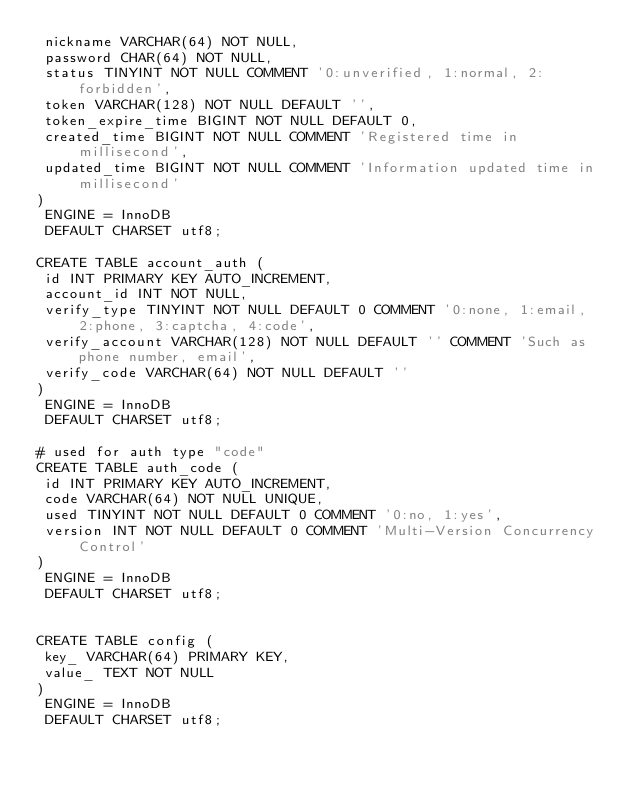<code> <loc_0><loc_0><loc_500><loc_500><_SQL_> nickname VARCHAR(64) NOT NULL,
 password CHAR(64) NOT NULL,
 status TINYINT NOT NULL COMMENT '0:unverified, 1:normal, 2:forbidden',
 token VARCHAR(128) NOT NULL DEFAULT '',
 token_expire_time BIGINT NOT NULL DEFAULT 0,
 created_time BIGINT NOT NULL COMMENT 'Registered time in millisecond',
 updated_time BIGINT NOT NULL COMMENT 'Information updated time in millisecond'
)
 ENGINE = InnoDB
 DEFAULT CHARSET utf8;

CREATE TABLE account_auth (
 id INT PRIMARY KEY AUTO_INCREMENT,
 account_id INT NOT NULL,
 verify_type TINYINT NOT NULL DEFAULT 0 COMMENT '0:none, 1:email, 2:phone, 3:captcha, 4:code',
 verify_account VARCHAR(128) NOT NULL DEFAULT '' COMMENT 'Such as phone number, email',
 verify_code VARCHAR(64) NOT NULL DEFAULT ''
)
 ENGINE = InnoDB
 DEFAULT CHARSET utf8;

# used for auth type "code"
CREATE TABLE auth_code (
 id INT PRIMARY KEY AUTO_INCREMENT,
 code VARCHAR(64) NOT NULL UNIQUE,
 used TINYINT NOT NULL DEFAULT 0 COMMENT '0:no, 1:yes',
 version INT NOT NULL DEFAULT 0 COMMENT 'Multi-Version Concurrency Control'
)
 ENGINE = InnoDB
 DEFAULT CHARSET utf8;


CREATE TABLE config (
 key_ VARCHAR(64) PRIMARY KEY,
 value_ TEXT NOT NULL
)
 ENGINE = InnoDB
 DEFAULT CHARSET utf8;
</code> 